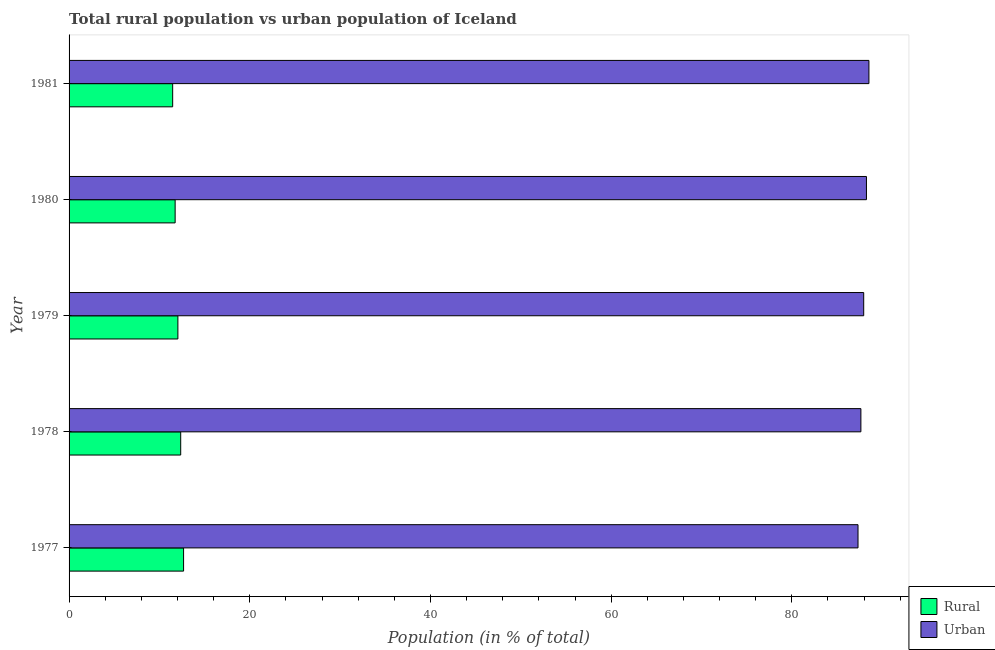How many groups of bars are there?
Ensure brevity in your answer.  5. Are the number of bars per tick equal to the number of legend labels?
Offer a very short reply. Yes. What is the rural population in 1980?
Your response must be concise. 11.74. Across all years, what is the maximum urban population?
Offer a terse response. 88.53. Across all years, what is the minimum rural population?
Offer a terse response. 11.47. In which year was the rural population maximum?
Make the answer very short. 1977. What is the total urban population in the graph?
Offer a terse response. 439.72. What is the difference between the rural population in 1980 and that in 1981?
Provide a short and direct response. 0.27. What is the difference between the rural population in 1981 and the urban population in 1978?
Offer a very short reply. -76.18. What is the average rural population per year?
Offer a terse response. 12.06. In the year 1977, what is the difference between the urban population and rural population?
Offer a very short reply. 74.65. What is the ratio of the rural population in 1978 to that in 1981?
Give a very brief answer. 1.08. What is the difference between the highest and the second highest rural population?
Your response must be concise. 0.32. What is the difference between the highest and the lowest rural population?
Make the answer very short. 1.21. In how many years, is the rural population greater than the average rural population taken over all years?
Give a very brief answer. 2. Is the sum of the rural population in 1977 and 1979 greater than the maximum urban population across all years?
Provide a short and direct response. No. What does the 1st bar from the top in 1980 represents?
Keep it short and to the point. Urban. What does the 2nd bar from the bottom in 1979 represents?
Keep it short and to the point. Urban. How many bars are there?
Offer a very short reply. 10. How many years are there in the graph?
Keep it short and to the point. 5. What is the difference between two consecutive major ticks on the X-axis?
Your response must be concise. 20. Does the graph contain any zero values?
Your answer should be compact. No. Does the graph contain grids?
Ensure brevity in your answer.  No. Where does the legend appear in the graph?
Provide a short and direct response. Bottom right. How many legend labels are there?
Provide a short and direct response. 2. How are the legend labels stacked?
Keep it short and to the point. Vertical. What is the title of the graph?
Your answer should be compact. Total rural population vs urban population of Iceland. Does "Diesel" appear as one of the legend labels in the graph?
Keep it short and to the point. No. What is the label or title of the X-axis?
Keep it short and to the point. Population (in % of total). What is the label or title of the Y-axis?
Keep it short and to the point. Year. What is the Population (in % of total) in Rural in 1977?
Ensure brevity in your answer.  12.67. What is the Population (in % of total) in Urban in 1977?
Provide a short and direct response. 87.33. What is the Population (in % of total) in Rural in 1978?
Offer a terse response. 12.36. What is the Population (in % of total) in Urban in 1978?
Ensure brevity in your answer.  87.64. What is the Population (in % of total) of Rural in 1979?
Your response must be concise. 12.04. What is the Population (in % of total) in Urban in 1979?
Your answer should be very brief. 87.95. What is the Population (in % of total) in Rural in 1980?
Offer a terse response. 11.74. What is the Population (in % of total) in Urban in 1980?
Ensure brevity in your answer.  88.26. What is the Population (in % of total) of Rural in 1981?
Make the answer very short. 11.47. What is the Population (in % of total) of Urban in 1981?
Ensure brevity in your answer.  88.53. Across all years, what is the maximum Population (in % of total) of Rural?
Provide a succinct answer. 12.67. Across all years, what is the maximum Population (in % of total) in Urban?
Your answer should be very brief. 88.53. Across all years, what is the minimum Population (in % of total) of Rural?
Your answer should be very brief. 11.47. Across all years, what is the minimum Population (in % of total) of Urban?
Provide a succinct answer. 87.33. What is the total Population (in % of total) of Rural in the graph?
Offer a terse response. 60.28. What is the total Population (in % of total) of Urban in the graph?
Keep it short and to the point. 439.72. What is the difference between the Population (in % of total) in Rural in 1977 and that in 1978?
Ensure brevity in your answer.  0.32. What is the difference between the Population (in % of total) in Urban in 1977 and that in 1978?
Offer a terse response. -0.32. What is the difference between the Population (in % of total) in Rural in 1977 and that in 1979?
Make the answer very short. 0.63. What is the difference between the Population (in % of total) in Urban in 1977 and that in 1979?
Your answer should be compact. -0.63. What is the difference between the Population (in % of total) of Rural in 1977 and that in 1980?
Offer a terse response. 0.93. What is the difference between the Population (in % of total) in Urban in 1977 and that in 1980?
Keep it short and to the point. -0.93. What is the difference between the Population (in % of total) in Rural in 1977 and that in 1981?
Keep it short and to the point. 1.21. What is the difference between the Population (in % of total) of Urban in 1977 and that in 1981?
Offer a terse response. -1.21. What is the difference between the Population (in % of total) in Rural in 1978 and that in 1979?
Keep it short and to the point. 0.31. What is the difference between the Population (in % of total) of Urban in 1978 and that in 1979?
Ensure brevity in your answer.  -0.31. What is the difference between the Population (in % of total) of Rural in 1978 and that in 1980?
Your response must be concise. 0.62. What is the difference between the Population (in % of total) of Urban in 1978 and that in 1980?
Keep it short and to the point. -0.62. What is the difference between the Population (in % of total) of Rural in 1978 and that in 1981?
Ensure brevity in your answer.  0.89. What is the difference between the Population (in % of total) in Urban in 1978 and that in 1981?
Your answer should be very brief. -0.89. What is the difference between the Population (in % of total) in Rural in 1979 and that in 1980?
Ensure brevity in your answer.  0.3. What is the difference between the Population (in % of total) in Urban in 1979 and that in 1980?
Provide a succinct answer. -0.3. What is the difference between the Population (in % of total) of Rural in 1979 and that in 1981?
Offer a very short reply. 0.58. What is the difference between the Population (in % of total) of Urban in 1979 and that in 1981?
Provide a succinct answer. -0.58. What is the difference between the Population (in % of total) of Rural in 1980 and that in 1981?
Offer a terse response. 0.27. What is the difference between the Population (in % of total) of Urban in 1980 and that in 1981?
Make the answer very short. -0.27. What is the difference between the Population (in % of total) of Rural in 1977 and the Population (in % of total) of Urban in 1978?
Give a very brief answer. -74.97. What is the difference between the Population (in % of total) of Rural in 1977 and the Population (in % of total) of Urban in 1979?
Give a very brief answer. -75.28. What is the difference between the Population (in % of total) of Rural in 1977 and the Population (in % of total) of Urban in 1980?
Your answer should be very brief. -75.59. What is the difference between the Population (in % of total) of Rural in 1977 and the Population (in % of total) of Urban in 1981?
Your response must be concise. -75.86. What is the difference between the Population (in % of total) of Rural in 1978 and the Population (in % of total) of Urban in 1979?
Offer a terse response. -75.6. What is the difference between the Population (in % of total) of Rural in 1978 and the Population (in % of total) of Urban in 1980?
Make the answer very short. -75.9. What is the difference between the Population (in % of total) of Rural in 1978 and the Population (in % of total) of Urban in 1981?
Offer a terse response. -76.18. What is the difference between the Population (in % of total) in Rural in 1979 and the Population (in % of total) in Urban in 1980?
Your answer should be compact. -76.22. What is the difference between the Population (in % of total) of Rural in 1979 and the Population (in % of total) of Urban in 1981?
Offer a terse response. -76.49. What is the difference between the Population (in % of total) of Rural in 1980 and the Population (in % of total) of Urban in 1981?
Provide a succinct answer. -76.79. What is the average Population (in % of total) of Rural per year?
Your response must be concise. 12.06. What is the average Population (in % of total) of Urban per year?
Your response must be concise. 87.94. In the year 1977, what is the difference between the Population (in % of total) of Rural and Population (in % of total) of Urban?
Offer a very short reply. -74.65. In the year 1978, what is the difference between the Population (in % of total) of Rural and Population (in % of total) of Urban?
Your response must be concise. -75.29. In the year 1979, what is the difference between the Population (in % of total) of Rural and Population (in % of total) of Urban?
Keep it short and to the point. -75.91. In the year 1980, what is the difference between the Population (in % of total) in Rural and Population (in % of total) in Urban?
Your answer should be compact. -76.52. In the year 1981, what is the difference between the Population (in % of total) in Rural and Population (in % of total) in Urban?
Offer a terse response. -77.07. What is the ratio of the Population (in % of total) in Rural in 1977 to that in 1978?
Your answer should be very brief. 1.03. What is the ratio of the Population (in % of total) of Urban in 1977 to that in 1978?
Offer a very short reply. 1. What is the ratio of the Population (in % of total) in Rural in 1977 to that in 1979?
Provide a short and direct response. 1.05. What is the ratio of the Population (in % of total) in Rural in 1977 to that in 1980?
Make the answer very short. 1.08. What is the ratio of the Population (in % of total) in Urban in 1977 to that in 1980?
Provide a succinct answer. 0.99. What is the ratio of the Population (in % of total) of Rural in 1977 to that in 1981?
Provide a short and direct response. 1.11. What is the ratio of the Population (in % of total) in Urban in 1977 to that in 1981?
Give a very brief answer. 0.99. What is the ratio of the Population (in % of total) of Rural in 1978 to that in 1979?
Your answer should be compact. 1.03. What is the ratio of the Population (in % of total) of Urban in 1978 to that in 1979?
Your answer should be compact. 1. What is the ratio of the Population (in % of total) in Rural in 1978 to that in 1980?
Offer a very short reply. 1.05. What is the ratio of the Population (in % of total) in Rural in 1978 to that in 1981?
Provide a succinct answer. 1.08. What is the ratio of the Population (in % of total) in Rural in 1979 to that in 1981?
Give a very brief answer. 1.05. What is the ratio of the Population (in % of total) of Rural in 1980 to that in 1981?
Ensure brevity in your answer.  1.02. What is the difference between the highest and the second highest Population (in % of total) of Rural?
Provide a short and direct response. 0.32. What is the difference between the highest and the second highest Population (in % of total) in Urban?
Your response must be concise. 0.27. What is the difference between the highest and the lowest Population (in % of total) in Rural?
Provide a succinct answer. 1.21. What is the difference between the highest and the lowest Population (in % of total) of Urban?
Provide a succinct answer. 1.21. 